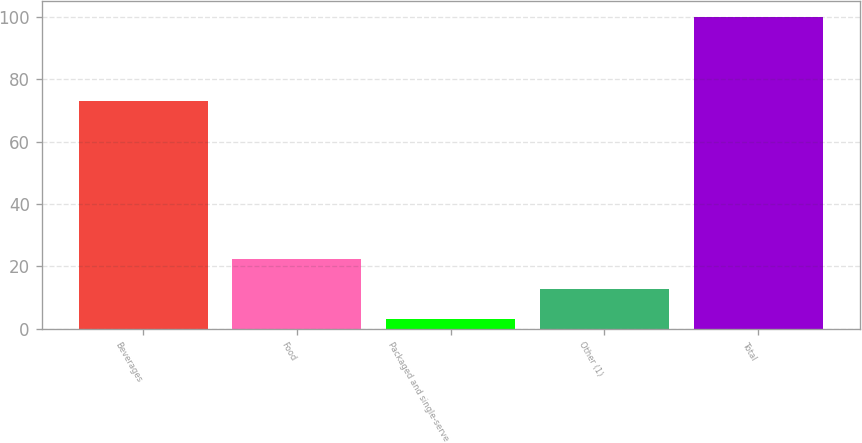Convert chart to OTSL. <chart><loc_0><loc_0><loc_500><loc_500><bar_chart><fcel>Beverages<fcel>Food<fcel>Packaged and single-serve<fcel>Other (1)<fcel>Total<nl><fcel>73<fcel>22.4<fcel>3<fcel>12.7<fcel>100<nl></chart> 